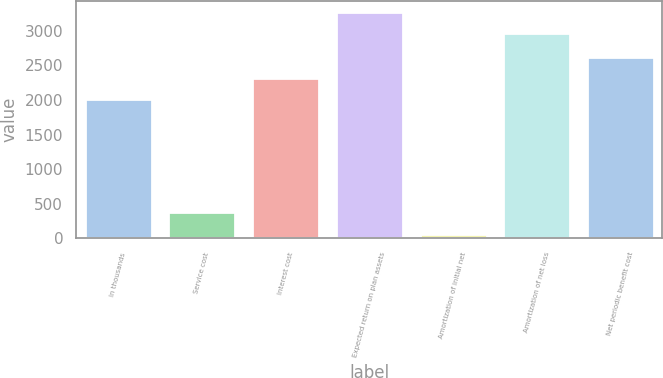<chart> <loc_0><loc_0><loc_500><loc_500><bar_chart><fcel>In thousands<fcel>Service cost<fcel>Interest cost<fcel>Expected return on plan assets<fcel>Amortization of initial net<fcel>Amortization of net loss<fcel>Net periodic benefit cost<nl><fcel>2012<fcel>379<fcel>2315.3<fcel>3271.3<fcel>62<fcel>2968<fcel>2618.6<nl></chart> 